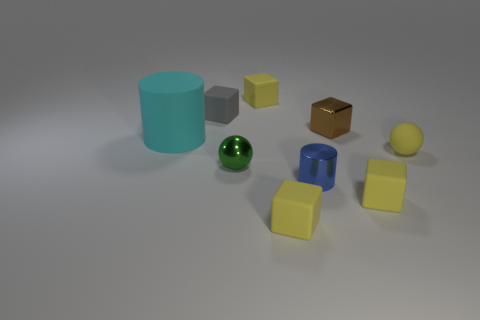Add 1 tiny brown things. How many objects exist? 10 Subtract all cylinders. How many objects are left? 7 Subtract 1 spheres. How many spheres are left? 1 Subtract all green blocks. Subtract all cyan cylinders. How many blocks are left? 5 Subtract all red blocks. How many blue cylinders are left? 1 Subtract all tiny green spheres. Subtract all small purple balls. How many objects are left? 8 Add 1 cubes. How many cubes are left? 6 Add 4 large purple rubber cylinders. How many large purple rubber cylinders exist? 4 Subtract all gray cubes. How many cubes are left? 4 Subtract all metallic blocks. How many blocks are left? 4 